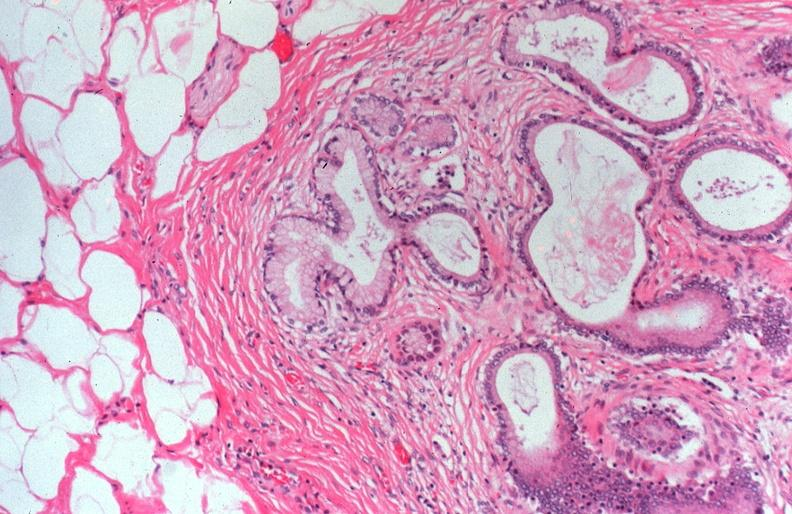what does this image show?
Answer the question using a single word or phrase. Cystic fibrosis 